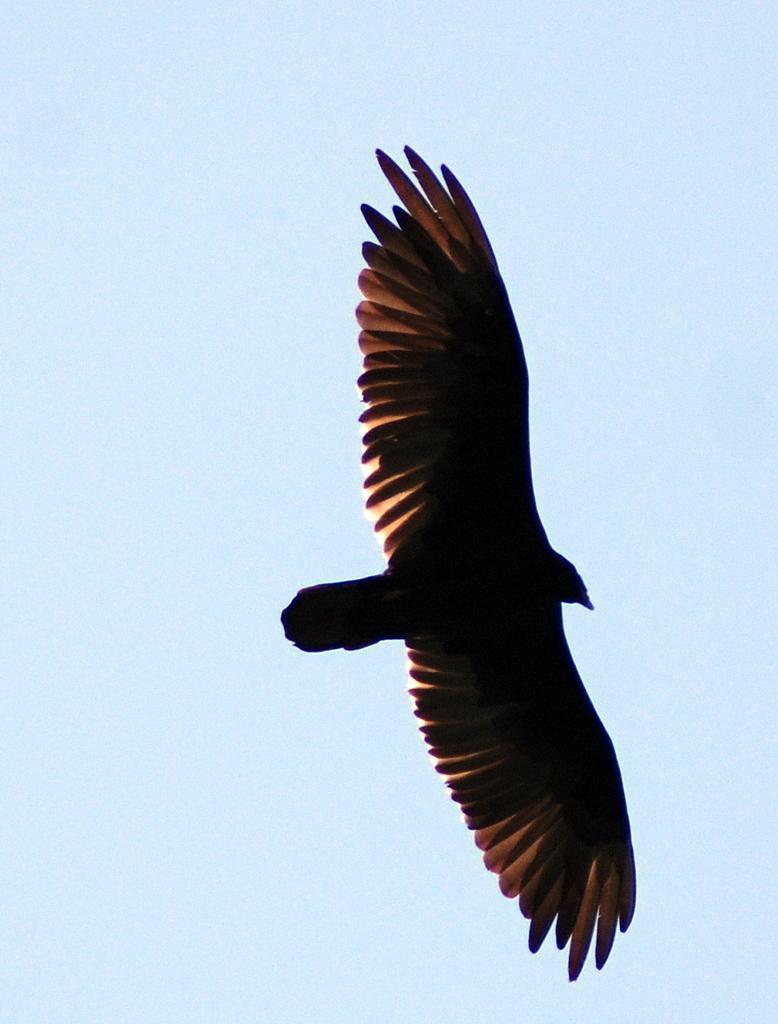In one or two sentences, can you explain what this image depicts? In the image we can see there is a bird flying in the sky and the sky is clear. 